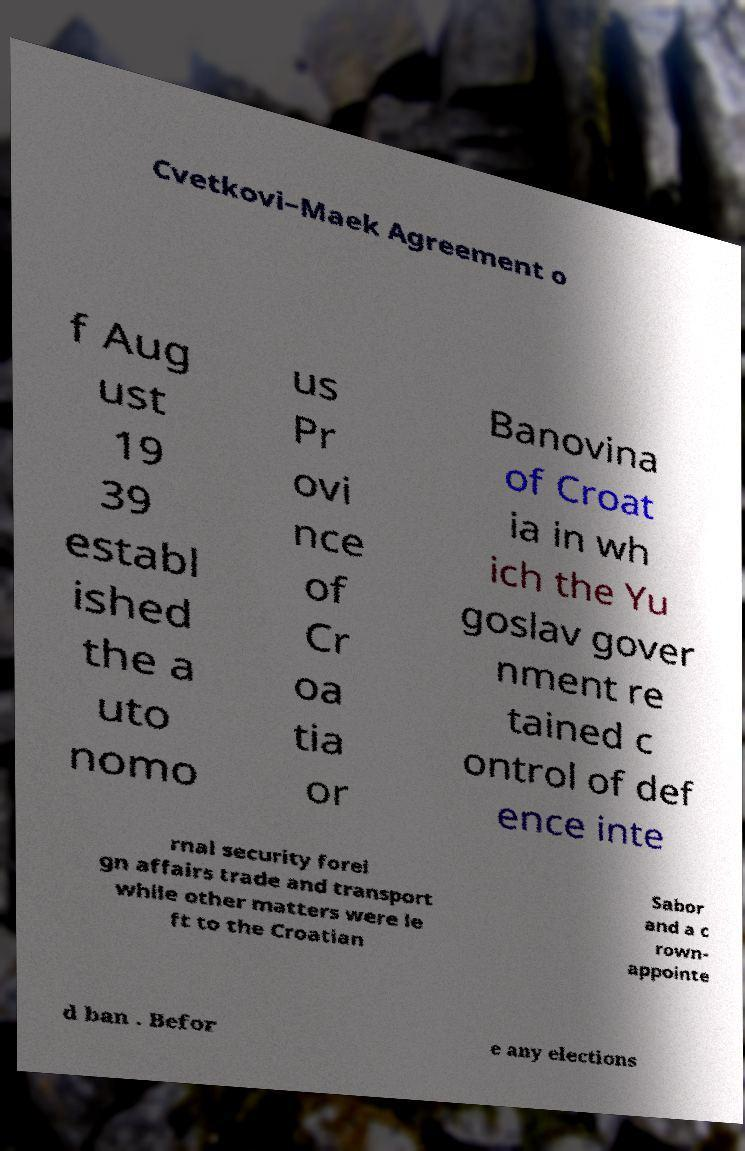Please read and relay the text visible in this image. What does it say? Cvetkovi–Maek Agreement o f Aug ust 19 39 establ ished the a uto nomo us Pr ovi nce of Cr oa tia or Banovina of Croat ia in wh ich the Yu goslav gover nment re tained c ontrol of def ence inte rnal security forei gn affairs trade and transport while other matters were le ft to the Croatian Sabor and a c rown- appointe d ban . Befor e any elections 